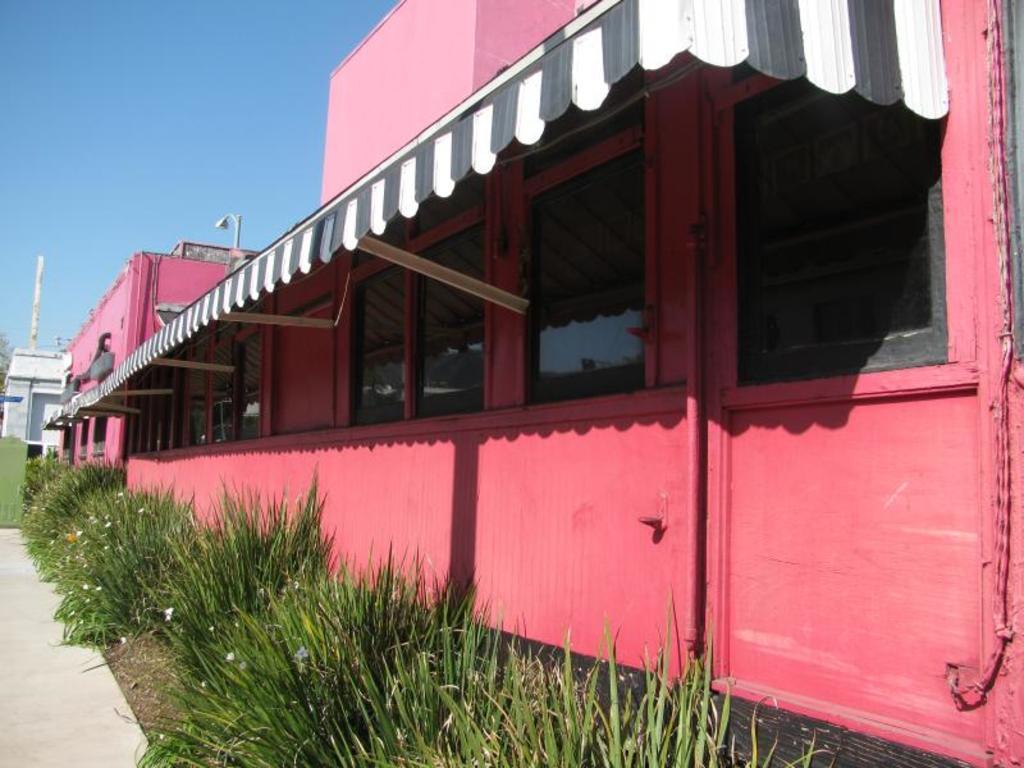Could you give a brief overview of what you see in this image? In this image we can see buildings, a shed attached to the building and there are few plants in front of the building and the sky in the background. 